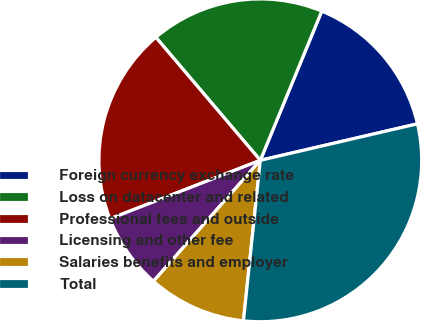Convert chart to OTSL. <chart><loc_0><loc_0><loc_500><loc_500><pie_chart><fcel>Foreign currency exchange rate<fcel>Loss on datacenter and related<fcel>Professional fees and outside<fcel>Licensing and other fee<fcel>Salaries benefits and employer<fcel>Total<nl><fcel>15.15%<fcel>17.42%<fcel>19.7%<fcel>7.58%<fcel>9.85%<fcel>30.3%<nl></chart> 